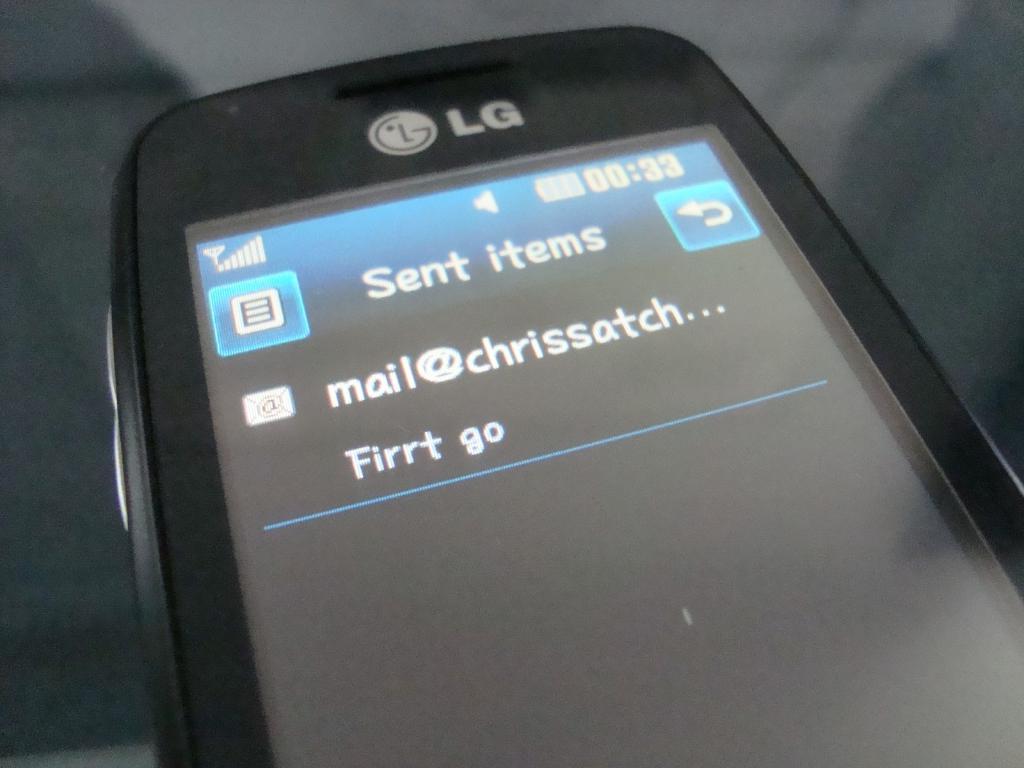What time is on the phone?
Your answer should be compact. 00:33. Who message it is?
Provide a short and direct response. Chrissatch. 